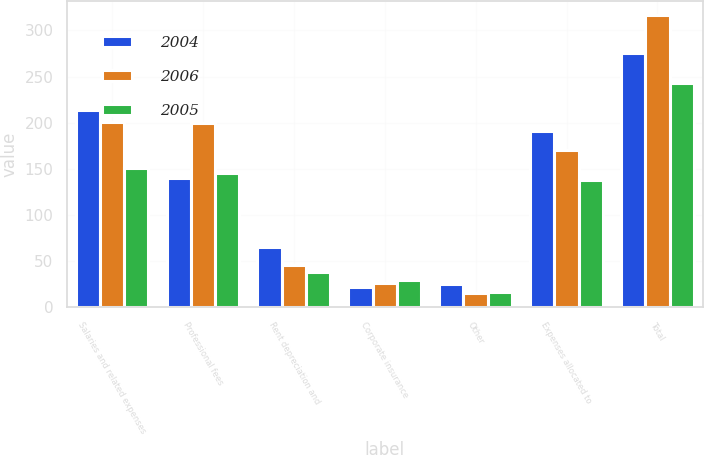Convert chart to OTSL. <chart><loc_0><loc_0><loc_500><loc_500><stacked_bar_chart><ecel><fcel>Salaries and related expenses<fcel>Professional fees<fcel>Rent depreciation and<fcel>Corporate insurance<fcel>Other<fcel>Expenses allocated to<fcel>Total<nl><fcel>2004<fcel>214.1<fcel>139.7<fcel>65.4<fcel>21.7<fcel>25.3<fcel>190.9<fcel>275.3<nl><fcel>2006<fcel>201.3<fcel>199.3<fcel>45.3<fcel>26<fcel>15.2<fcel>170.8<fcel>316.3<nl><fcel>2005<fcel>151.2<fcel>145.3<fcel>38.4<fcel>29.7<fcel>16.8<fcel>138.2<fcel>243.2<nl></chart> 